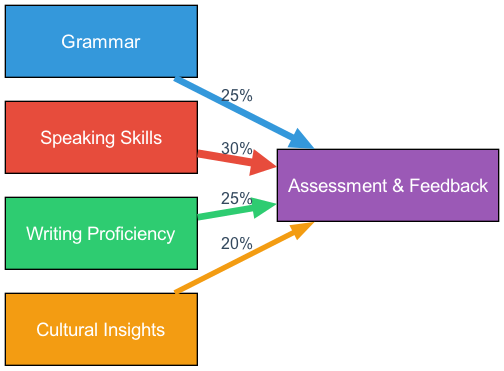What percentage of time is allocated to grammar in the assessment? The diagram shows a flow from the Grammar node to the Assessment node. The label on the edge indicates a value of 25% representing the time spent on grammar in the assessment.
Answer: 25% Which component has the highest allocation in the assessment? By comparing the values of the edges that connect the components to the Assessment node, the Speaking component has a value of 30%, which is higher than the others (25% for Grammar and Writing, and 20% for Culture).
Answer: Speaking How many components contribute to the assessment? The diagram has four nodes (Grammar, Speaking, Writing, and Culture) that each connect to the Assessment node, indicating that there are four components contributing to the assessment.
Answer: 4 What is the total percentage of time spent on Writing and Culture combined? The value for Writing is 25% and for Culture it is 20%. Adding these two values together (25% + 20%) gives a total of 45% for both components combined.
Answer: 45% Which two components contribute equally to the assessment? The edges leading from the Grammar node and the Writing node both have a value of 25%, indicating they contribute equally to the assessment.
Answer: Grammar and Writing 